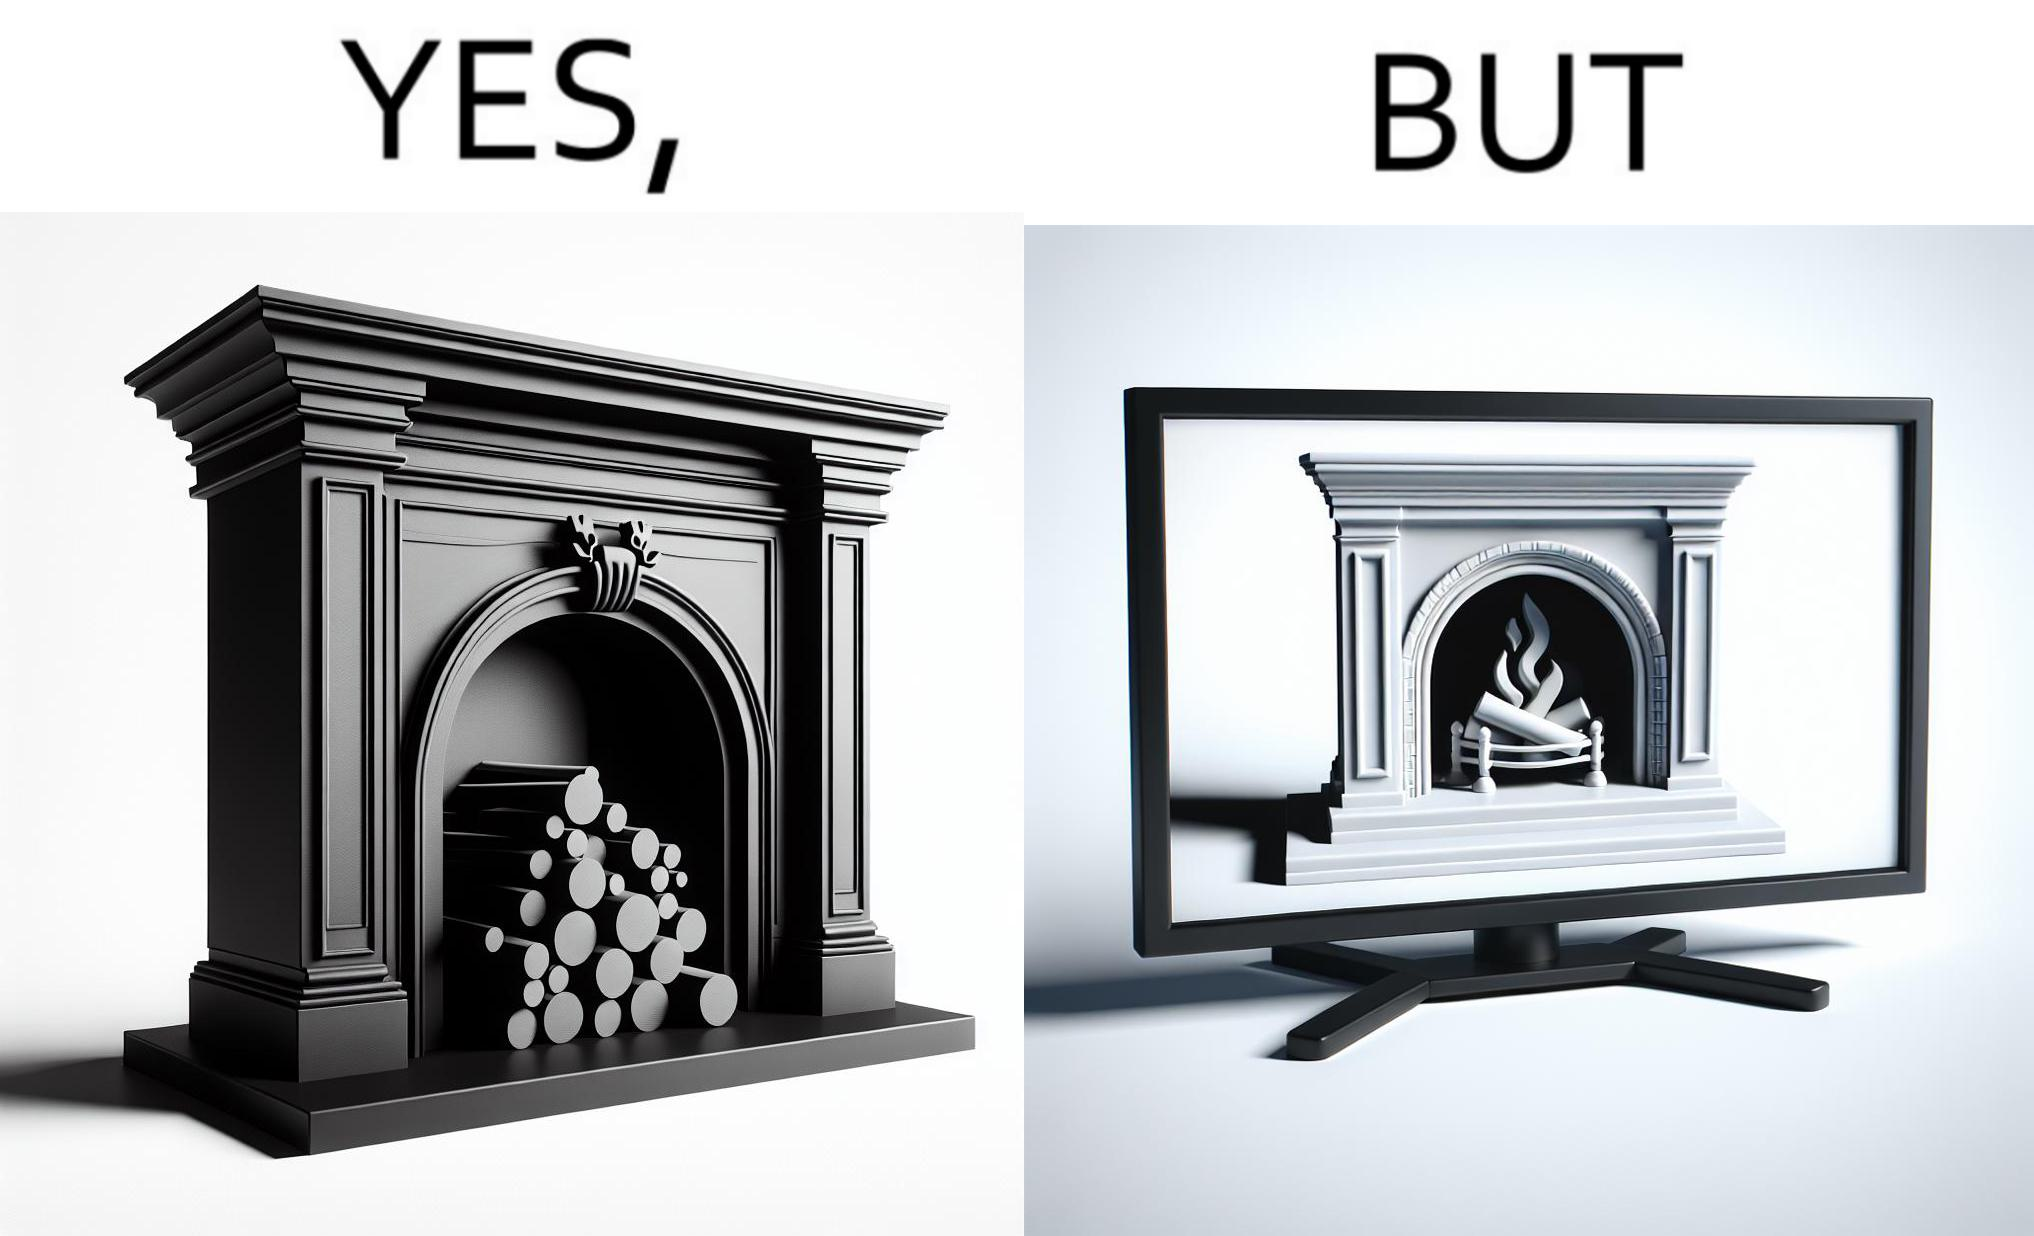Does this image contain satire or humor? Yes, this image is satirical. 